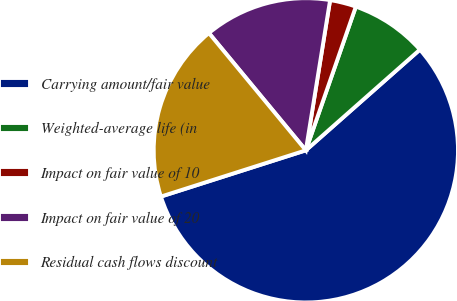Convert chart to OTSL. <chart><loc_0><loc_0><loc_500><loc_500><pie_chart><fcel>Carrying amount/fair value<fcel>Weighted-average life (in<fcel>Impact on fair value of 10<fcel>Impact on fair value of 20<fcel>Residual cash flows discount<nl><fcel>56.59%<fcel>8.16%<fcel>2.78%<fcel>13.54%<fcel>18.92%<nl></chart> 